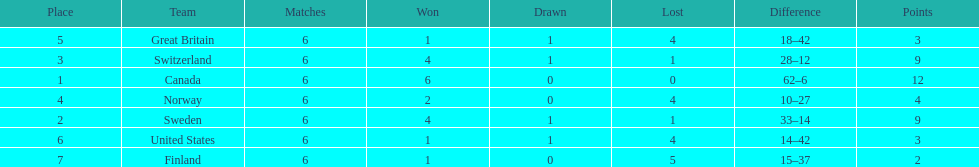In how many instances did teams secure at least four match wins? 3. 